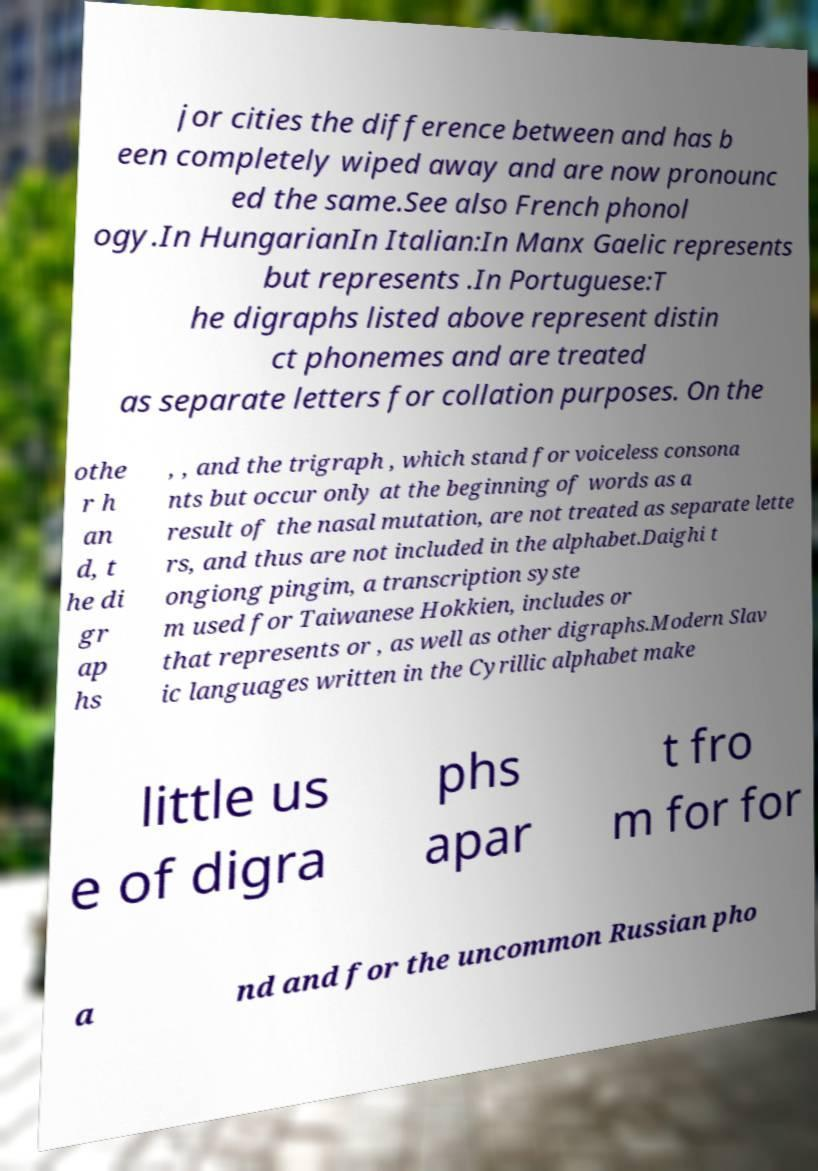Can you accurately transcribe the text from the provided image for me? jor cities the difference between and has b een completely wiped away and are now pronounc ed the same.See also French phonol ogy.In HungarianIn Italian:In Manx Gaelic represents but represents .In Portuguese:T he digraphs listed above represent distin ct phonemes and are treated as separate letters for collation purposes. On the othe r h an d, t he di gr ap hs , , and the trigraph , which stand for voiceless consona nts but occur only at the beginning of words as a result of the nasal mutation, are not treated as separate lette rs, and thus are not included in the alphabet.Daighi t ongiong pingim, a transcription syste m used for Taiwanese Hokkien, includes or that represents or , as well as other digraphs.Modern Slav ic languages written in the Cyrillic alphabet make little us e of digra phs apar t fro m for for a nd and for the uncommon Russian pho 